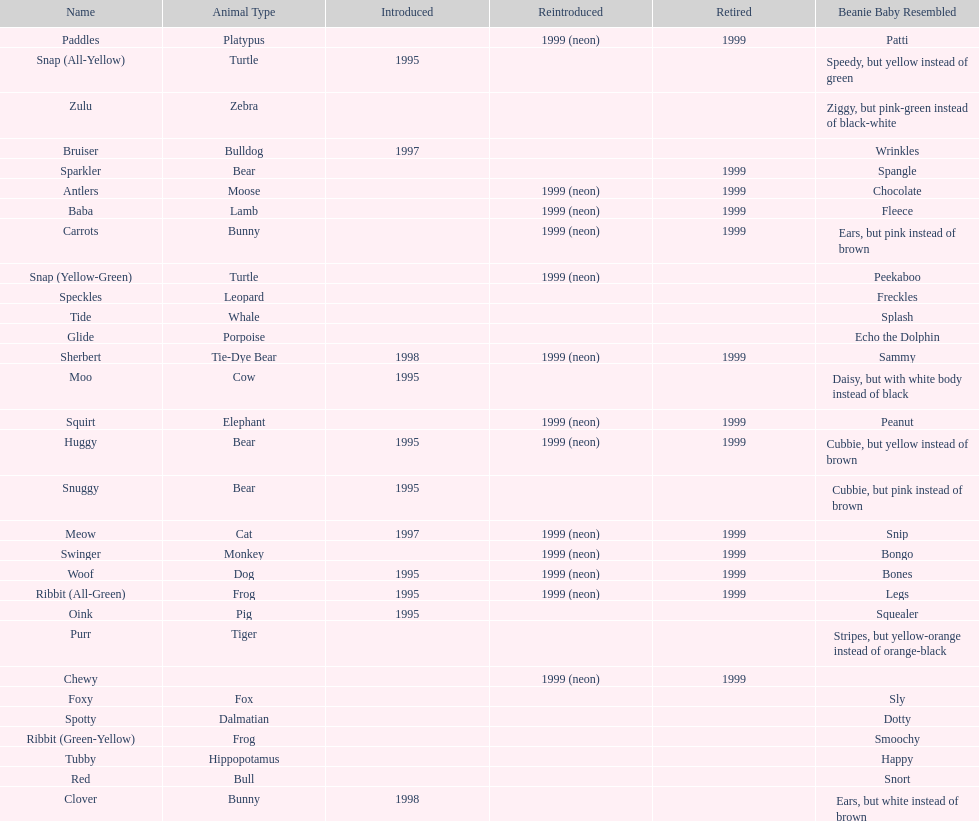How long was woof the dog sold before it was retired? 4 years. 